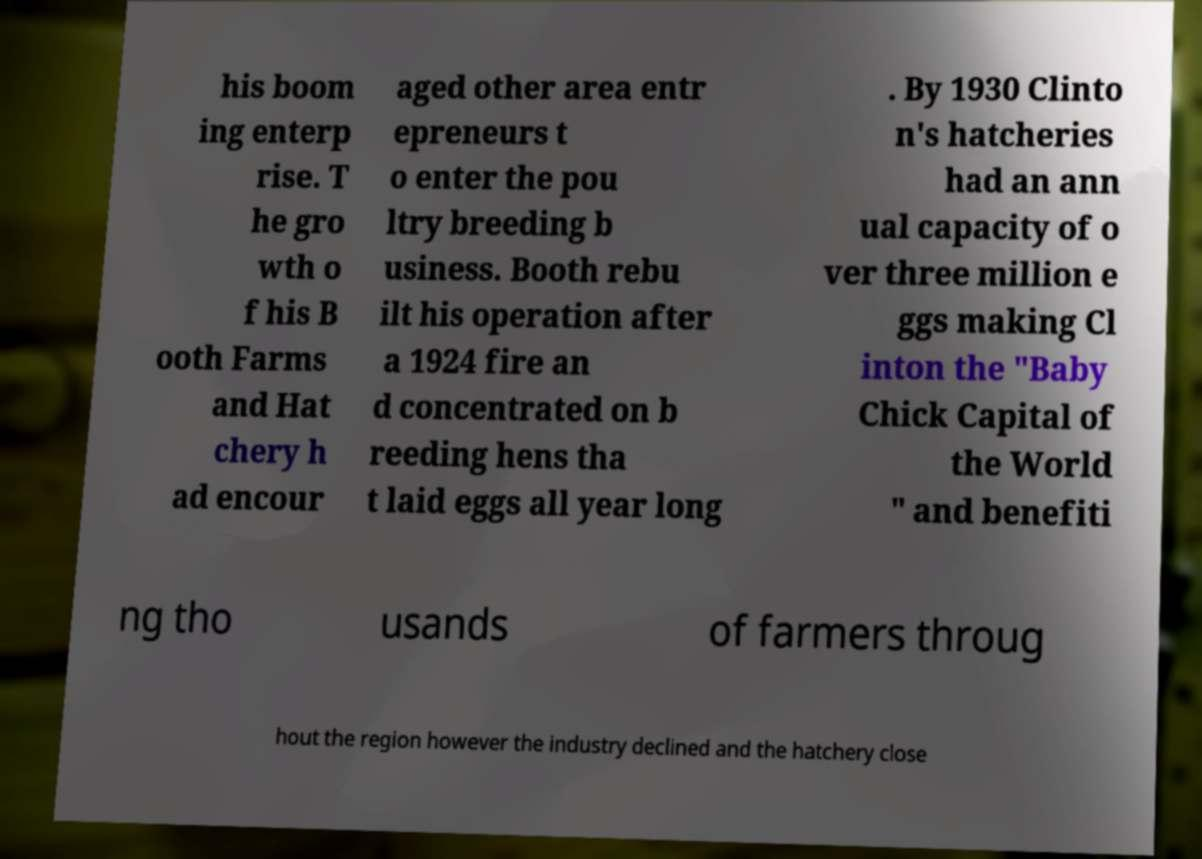Could you assist in decoding the text presented in this image and type it out clearly? his boom ing enterp rise. T he gro wth o f his B ooth Farms and Hat chery h ad encour aged other area entr epreneurs t o enter the pou ltry breeding b usiness. Booth rebu ilt his operation after a 1924 fire an d concentrated on b reeding hens tha t laid eggs all year long . By 1930 Clinto n's hatcheries had an ann ual capacity of o ver three million e ggs making Cl inton the "Baby Chick Capital of the World " and benefiti ng tho usands of farmers throug hout the region however the industry declined and the hatchery close 